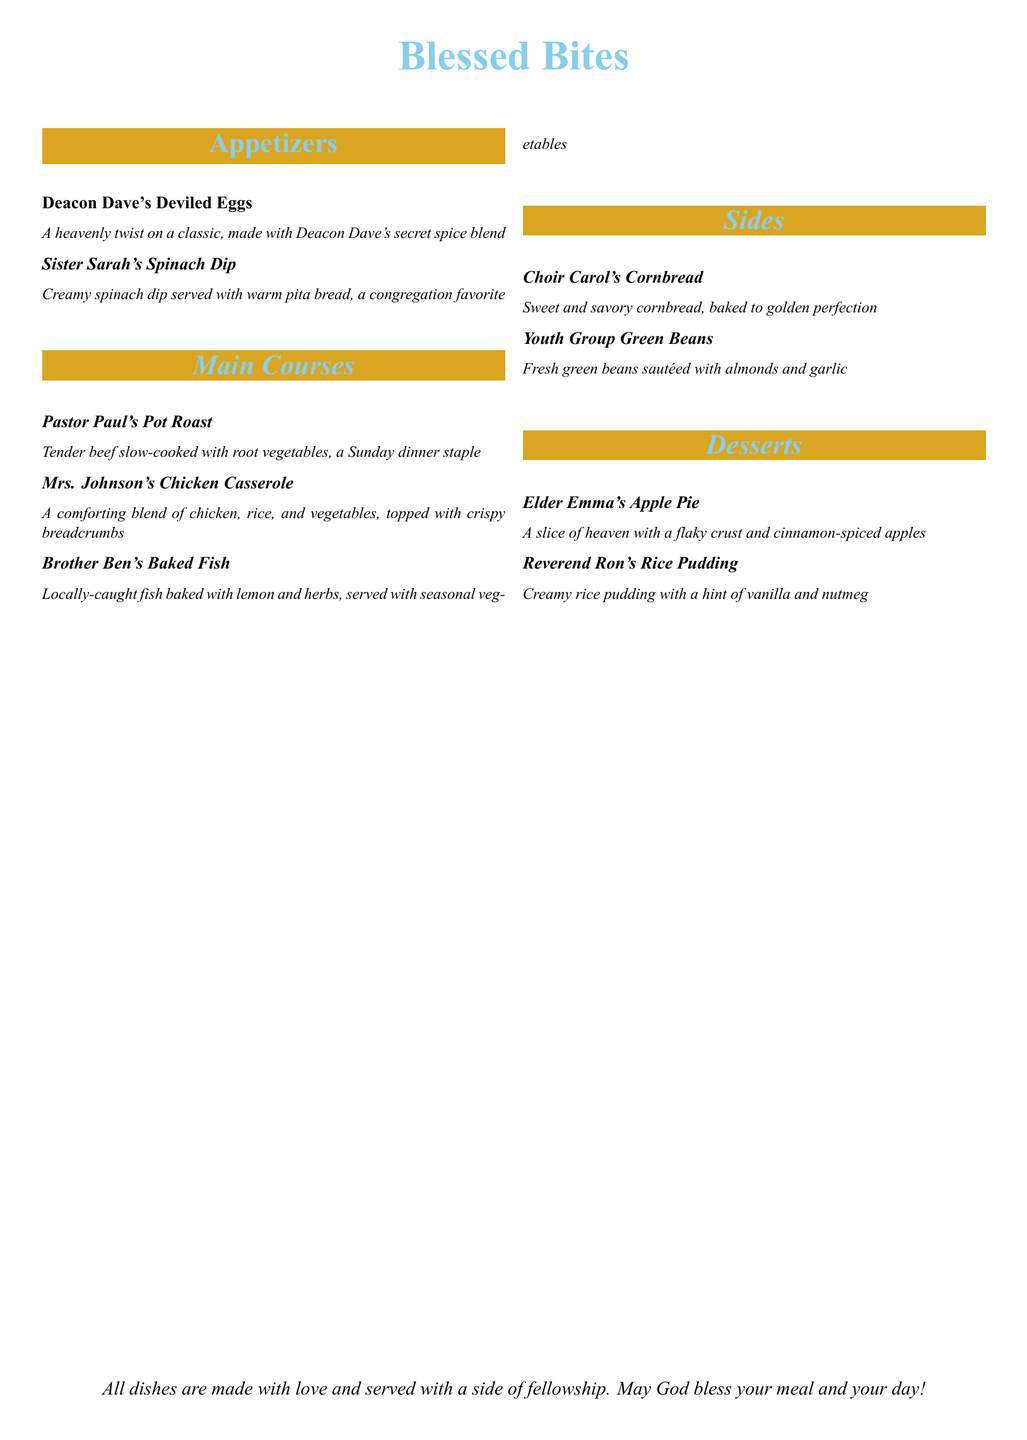What are the appetizers listed? The appetizers listed in the menu are Deacon Dave's Deviled Eggs and Sister Sarah's Spinach Dip.
Answer: Deacon Dave's Deviled Eggs, Sister Sarah's Spinach Dip Who is the main course named after a pastor? The main course named after a pastor is Pastor Paul's Pot Roast.
Answer: Pastor Paul's Pot Roast What dish is served with seasonal vegetables? Brother Ben's Baked Fish is the dish that is served with seasonal vegetables.
Answer: Brother Ben's Baked Fish How many desserts are listed in the menu? The menu lists two desserts: Elder Emma's Apple Pie and Reverend Ron's Rice Pudding.
Answer: Two What is the color of the cornbread described? The cornbread is described as sweet and savory, baked to golden perfection.
Answer: Golden What type of dish is Sister Sarah's Spinach Dip? Sister Sarah's Spinach Dip is a creamy spinach dip served with warm pita bread.
Answer: Creamy spinach dip Which dish contains chicken? Mrs. Johnson's Chicken Casserole contains chicken.
Answer: Mrs. Johnson's Chicken Casserole What is the flavor hint in Reverend Ron's Rice Pudding? The flavor hint in Reverend Ron's Rice Pudding is vanilla and nutmeg.
Answer: Vanilla and nutmeg 